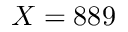<formula> <loc_0><loc_0><loc_500><loc_500>X = 8 8 9</formula> 